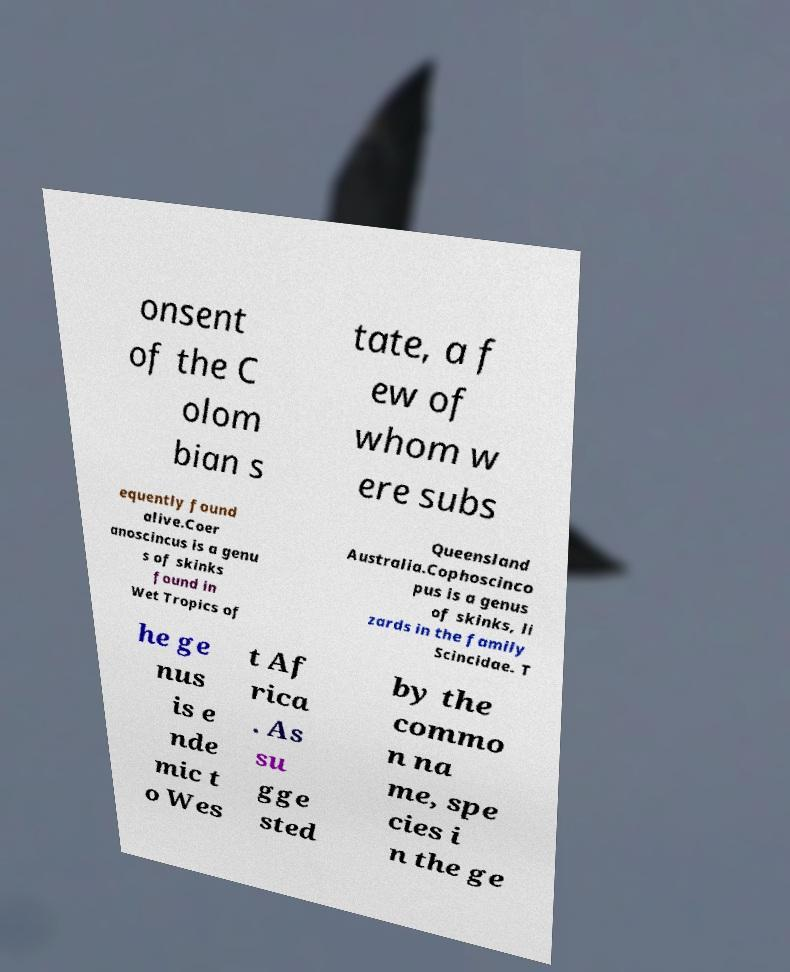Please identify and transcribe the text found in this image. onsent of the C olom bian s tate, a f ew of whom w ere subs equently found alive.Coer anoscincus is a genu s of skinks found in Wet Tropics of Queensland Australia.Cophoscinco pus is a genus of skinks, li zards in the family Scincidae. T he ge nus is e nde mic t o Wes t Af rica . As su gge sted by the commo n na me, spe cies i n the ge 